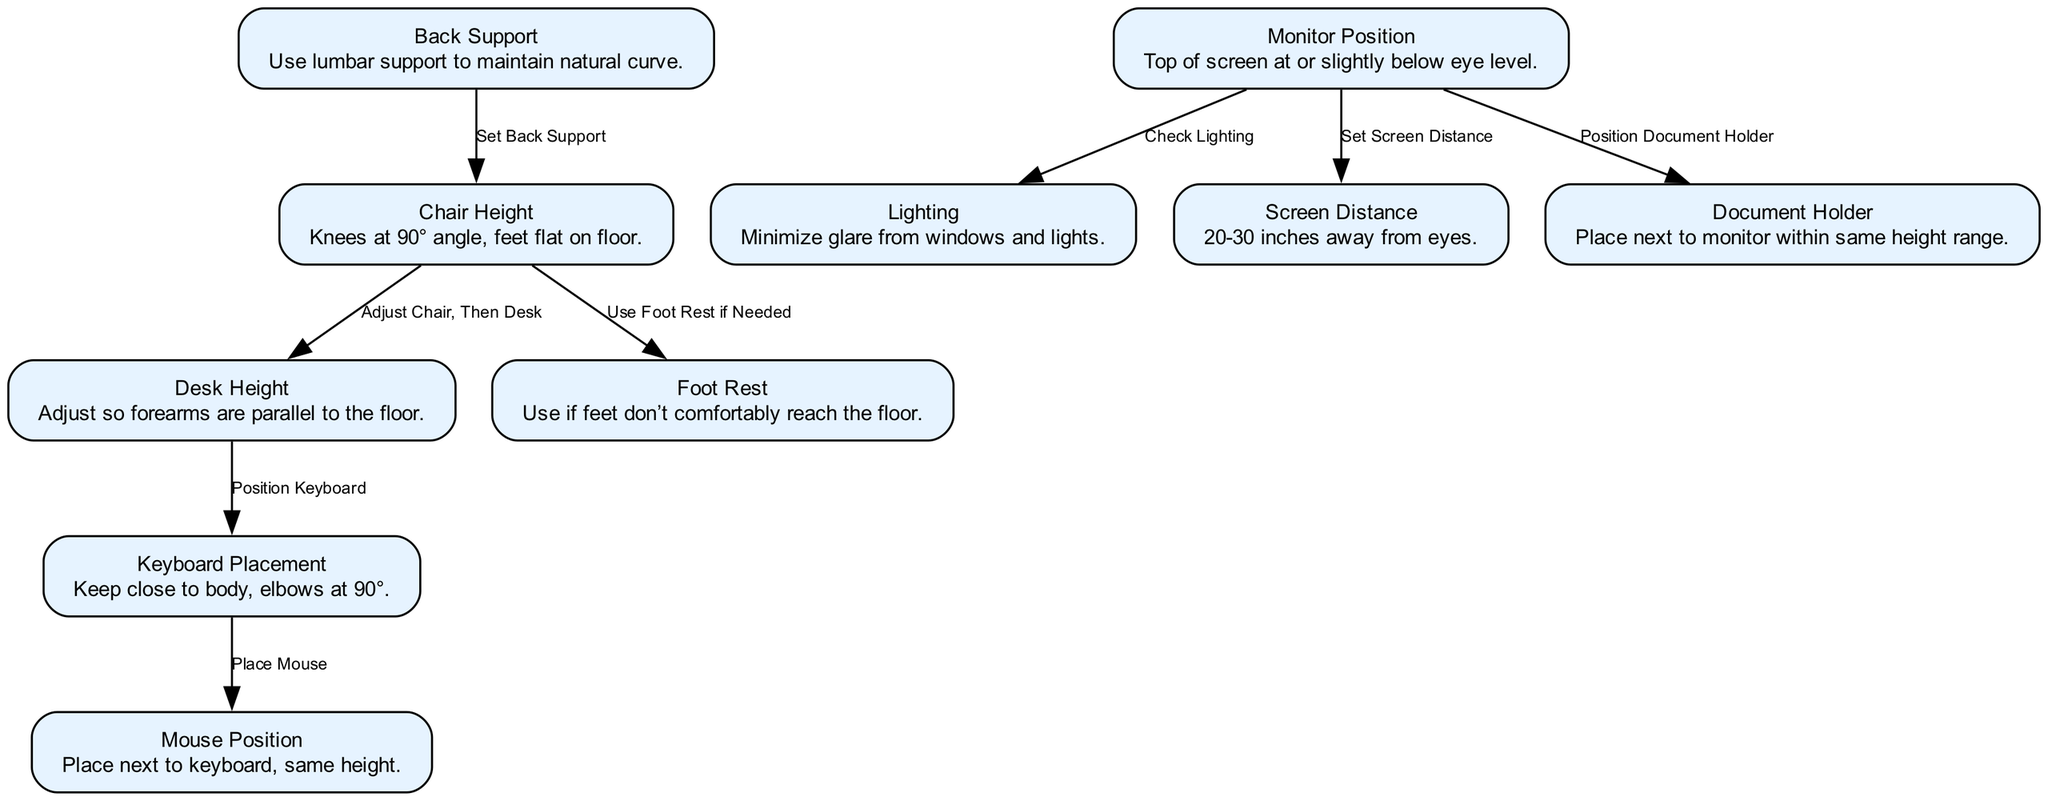What is the first step to adjust chair height? The diagram indicates that the chair height should be set to ensure that the knees are at a 90° angle with feet flat on the floor. This is the foundational step before making any other adjustments.
Answer: Knees at 90° angle, feet flat on floor What is the maximum distance for screen placement? According to the diagram, the screen should be positioned between 20 to 30 inches away from the eyes, which is essential for maintaining visual comfort and reducing strain.
Answer: 30 inches Which element should be checked after positioning the monitor? The diagram advises checking the lighting after positioning the monitor to minimize glare, which can affect visibility and comfort. This relationship shows that the monitor setting directly influences integrated factors like lighting.
Answer: Check Lighting What must be adjusted first in relation to the desk and chair? The diagram highlights the edge labeled as "Adjust Chair, Then Desk," indicating that the first adjustment should be at the chair height before proceeding to adjust the desk height. This sequence is critical for proper ergonomics.
Answer: Adjust Chair How are the mouse and keyboard positioned in relation to each other? The diagram shows a direct connection from "Keyboard Placement" to "Mouse Position," indicating that the mouse should be placed next to the keyboard at the same height, ensuring a comfortable and efficient working posture.
Answer: Place next to keyboard, same height Which support should be used for maintaining the natural curve of the spine? The diagram specifies using lumbar support, which is labeled as "Back Support," to help in maintaining the natural curve of the spine while seated. This adjustment is important for preventing discomfort and injuries.
Answer: Use lumbar support What is the role of a document holder in an ergonomic setup? The diagram states that the document holder should be placed next to the monitor and within the same height range. This positioning helps to minimize neck strain by keeping documents at a comfortable viewing position.
Answer: Place next to monitor within same height range What is the importance of adjusting screen distance? The diagram points out that the screen distance plays a crucial role in enabling proper viewing without strain, as it should be set between 20 to 30 inches away from the eyes, facilitating good posture and comfort during work.
Answer: 20-30 inches away from eyes 